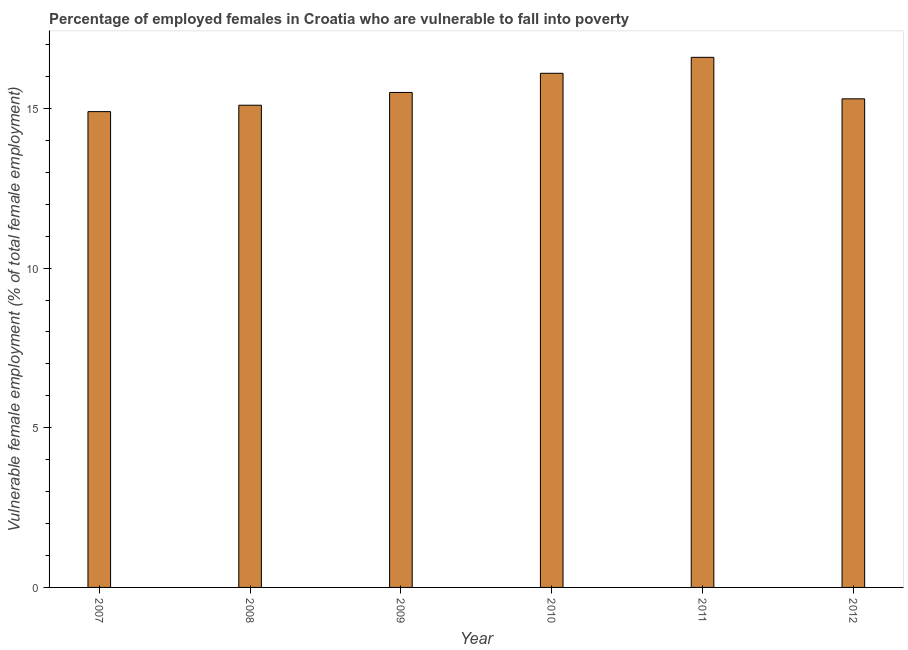Does the graph contain grids?
Ensure brevity in your answer.  No. What is the title of the graph?
Offer a terse response. Percentage of employed females in Croatia who are vulnerable to fall into poverty. What is the label or title of the Y-axis?
Offer a terse response. Vulnerable female employment (% of total female employment). What is the percentage of employed females who are vulnerable to fall into poverty in 2010?
Your response must be concise. 16.1. Across all years, what is the maximum percentage of employed females who are vulnerable to fall into poverty?
Make the answer very short. 16.6. Across all years, what is the minimum percentage of employed females who are vulnerable to fall into poverty?
Offer a terse response. 14.9. What is the sum of the percentage of employed females who are vulnerable to fall into poverty?
Offer a terse response. 93.5. What is the difference between the percentage of employed females who are vulnerable to fall into poverty in 2010 and 2012?
Offer a very short reply. 0.8. What is the average percentage of employed females who are vulnerable to fall into poverty per year?
Make the answer very short. 15.58. What is the median percentage of employed females who are vulnerable to fall into poverty?
Give a very brief answer. 15.4. What is the difference between the highest and the second highest percentage of employed females who are vulnerable to fall into poverty?
Your answer should be compact. 0.5. Is the sum of the percentage of employed females who are vulnerable to fall into poverty in 2011 and 2012 greater than the maximum percentage of employed females who are vulnerable to fall into poverty across all years?
Your response must be concise. Yes. What is the difference between the highest and the lowest percentage of employed females who are vulnerable to fall into poverty?
Make the answer very short. 1.7. In how many years, is the percentage of employed females who are vulnerable to fall into poverty greater than the average percentage of employed females who are vulnerable to fall into poverty taken over all years?
Provide a short and direct response. 2. What is the difference between two consecutive major ticks on the Y-axis?
Keep it short and to the point. 5. Are the values on the major ticks of Y-axis written in scientific E-notation?
Your answer should be compact. No. What is the Vulnerable female employment (% of total female employment) in 2007?
Your answer should be compact. 14.9. What is the Vulnerable female employment (% of total female employment) of 2008?
Offer a terse response. 15.1. What is the Vulnerable female employment (% of total female employment) of 2010?
Keep it short and to the point. 16.1. What is the Vulnerable female employment (% of total female employment) of 2011?
Your response must be concise. 16.6. What is the Vulnerable female employment (% of total female employment) in 2012?
Your response must be concise. 15.3. What is the difference between the Vulnerable female employment (% of total female employment) in 2007 and 2008?
Ensure brevity in your answer.  -0.2. What is the difference between the Vulnerable female employment (% of total female employment) in 2007 and 2011?
Ensure brevity in your answer.  -1.7. What is the difference between the Vulnerable female employment (% of total female employment) in 2007 and 2012?
Ensure brevity in your answer.  -0.4. What is the difference between the Vulnerable female employment (% of total female employment) in 2008 and 2011?
Keep it short and to the point. -1.5. What is the difference between the Vulnerable female employment (% of total female employment) in 2008 and 2012?
Provide a succinct answer. -0.2. What is the difference between the Vulnerable female employment (% of total female employment) in 2010 and 2012?
Ensure brevity in your answer.  0.8. What is the difference between the Vulnerable female employment (% of total female employment) in 2011 and 2012?
Keep it short and to the point. 1.3. What is the ratio of the Vulnerable female employment (% of total female employment) in 2007 to that in 2008?
Your answer should be compact. 0.99. What is the ratio of the Vulnerable female employment (% of total female employment) in 2007 to that in 2010?
Ensure brevity in your answer.  0.93. What is the ratio of the Vulnerable female employment (% of total female employment) in 2007 to that in 2011?
Offer a terse response. 0.9. What is the ratio of the Vulnerable female employment (% of total female employment) in 2008 to that in 2010?
Make the answer very short. 0.94. What is the ratio of the Vulnerable female employment (% of total female employment) in 2008 to that in 2011?
Your answer should be compact. 0.91. What is the ratio of the Vulnerable female employment (% of total female employment) in 2008 to that in 2012?
Offer a terse response. 0.99. What is the ratio of the Vulnerable female employment (% of total female employment) in 2009 to that in 2010?
Offer a terse response. 0.96. What is the ratio of the Vulnerable female employment (% of total female employment) in 2009 to that in 2011?
Your answer should be very brief. 0.93. What is the ratio of the Vulnerable female employment (% of total female employment) in 2010 to that in 2011?
Keep it short and to the point. 0.97. What is the ratio of the Vulnerable female employment (% of total female employment) in 2010 to that in 2012?
Provide a succinct answer. 1.05. What is the ratio of the Vulnerable female employment (% of total female employment) in 2011 to that in 2012?
Your answer should be compact. 1.08. 